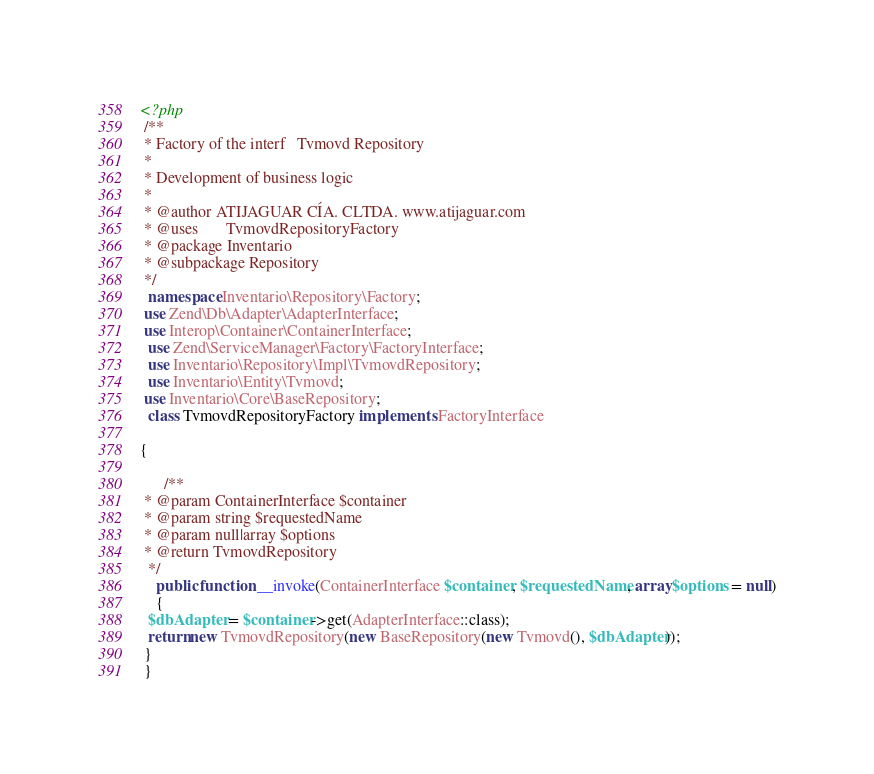Convert code to text. <code><loc_0><loc_0><loc_500><loc_500><_PHP_><?php
 /**
 * Factory of the interf   Tvmovd Repository
 *
 * Development of business logic
 *
 * @author ATIJAGUAR CÍA. CLTDA. www.atijaguar.com
 * @uses       TvmovdRepositoryFactory
 * @package Inventario
 * @subpackage Repository
 */
  namespace Inventario\Repository\Factory;
 use Zend\Db\Adapter\AdapterInterface;
 use Interop\Container\ContainerInterface;
  use Zend\ServiceManager\Factory\FactoryInterface;
  use Inventario\Repository\Impl\TvmovdRepository;
  use Inventario\Entity\Tvmovd;
 use Inventario\Core\BaseRepository;
  class TvmovdRepositoryFactory implements FactoryInterface
  
{

      /**
 * @param ContainerInterface $container
 * @param string $requestedName
 * @param null|array $options
 * @return TvmovdRepository
  */
    public function __invoke(ContainerInterface $container, $requestedName, array $options = null)
    {
  $dbAdapter = $container->get(AdapterInterface::class);
  return new TvmovdRepository(new BaseRepository(new Tvmovd(), $dbAdapter));
 }
 }
</code> 